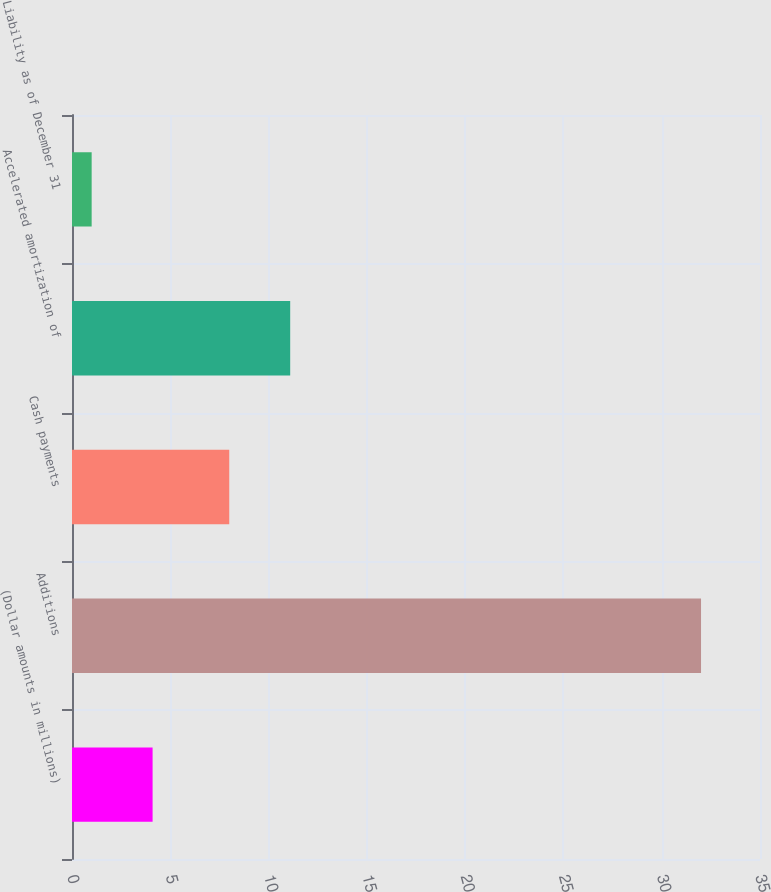<chart> <loc_0><loc_0><loc_500><loc_500><bar_chart><fcel>(Dollar amounts in millions)<fcel>Additions<fcel>Cash payments<fcel>Accelerated amortization of<fcel>Liability as of December 31<nl><fcel>4.1<fcel>32<fcel>8<fcel>11.1<fcel>1<nl></chart> 